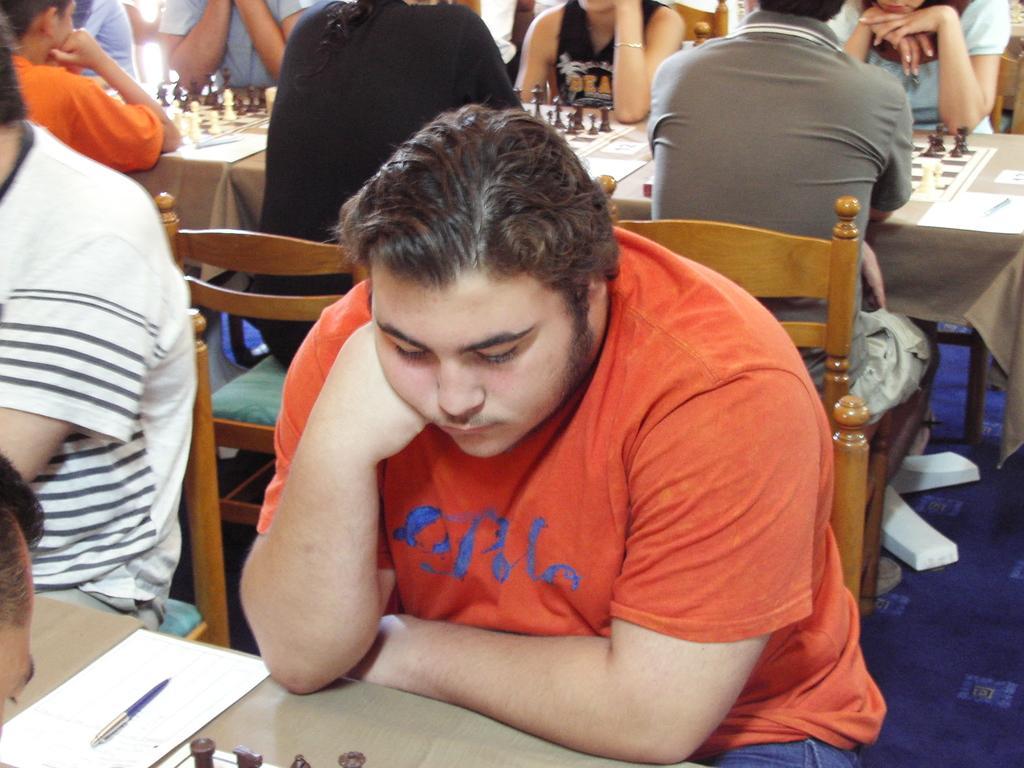Can you describe this image briefly? In this picture we can see a group of people sitting on chair and in front of them there is table and on table we can see chess board, paper, pen. 